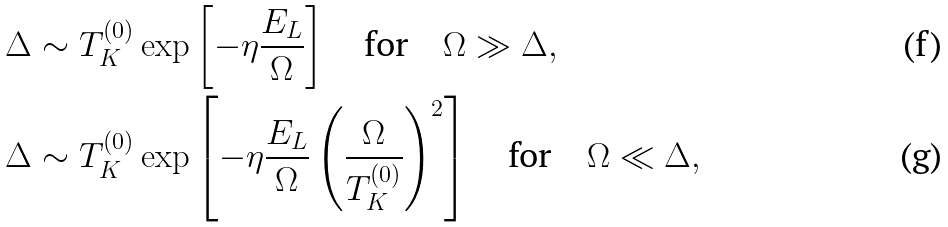Convert formula to latex. <formula><loc_0><loc_0><loc_500><loc_500>\Delta & \sim T _ { K } ^ { ( 0 ) } \exp \left [ - \eta \frac { E _ { L } } { \Omega } \right ] \quad \text {for} \quad \Omega \gg \Delta , \\ \Delta & \sim T _ { K } ^ { ( 0 ) } \exp \left [ - \eta \frac { E _ { L } } { \Omega } \left ( \frac { \Omega } { T _ { K } ^ { ( 0 ) } } \right ) ^ { 2 } \right ] \quad \text {for} \quad \Omega \ll \Delta ,</formula> 